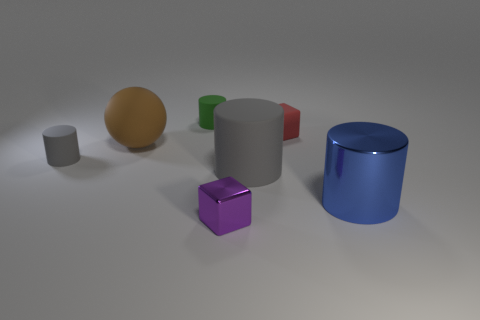Subtract all big metal cylinders. How many cylinders are left? 3 Add 2 big gray matte objects. How many objects exist? 9 Subtract all gray cylinders. How many cylinders are left? 2 Subtract all spheres. How many objects are left? 6 Subtract all brown cubes. Subtract all yellow balls. How many cubes are left? 2 Subtract all brown spheres. How many red cubes are left? 1 Subtract all brown matte spheres. Subtract all tiny purple things. How many objects are left? 5 Add 2 metallic things. How many metallic things are left? 4 Add 6 metallic spheres. How many metallic spheres exist? 6 Subtract 0 purple spheres. How many objects are left? 7 